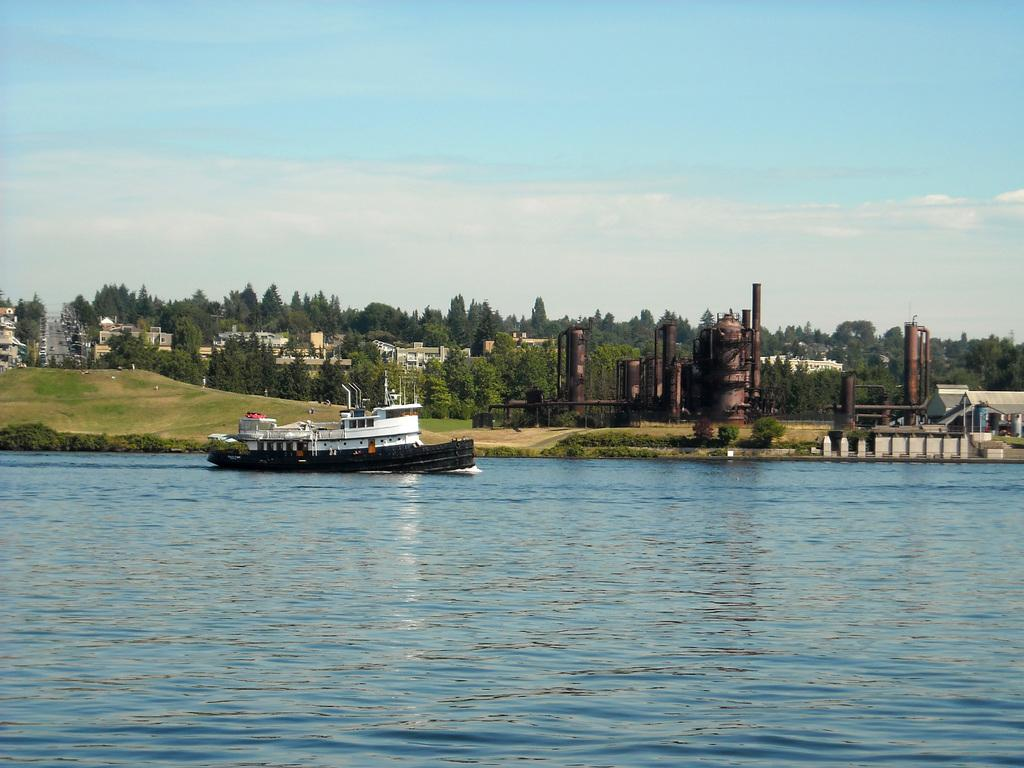What is the main subject of the image? The main subject of the image is a ship. Where is the ship located? The ship is on the water. What other structures or objects can be seen in the image? There are trees, buildings, factory equipment, and sheds in the image. What is visible in the sky in the image? The sky is visible in the image, and clouds are present. Is there a playground visible in the image? No, there is no playground present in the image. Does the existence of the ship in the image prove the existence of aliens? No, the existence of the ship in the image does not prove the existence of aliens, as it is likely a regular ship. What holiday is being celebrated in the image? There is no indication of a holiday being celebrated in the image. 